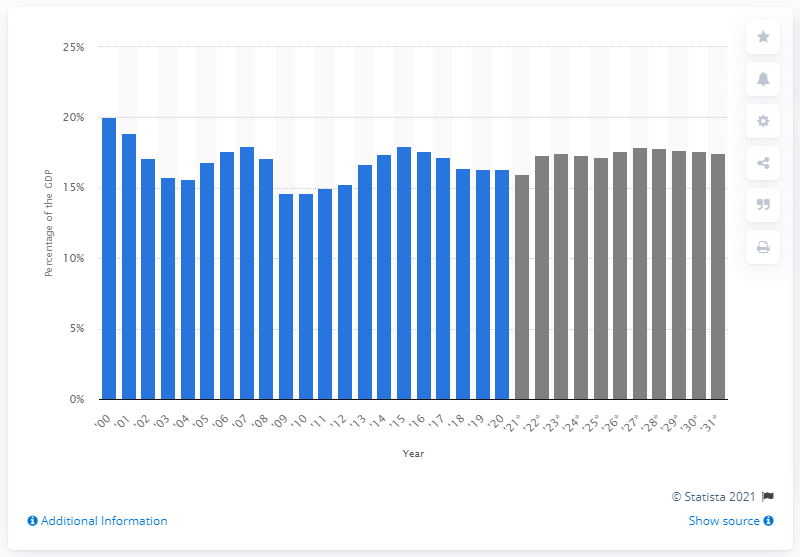Point out several critical features in this image. In 2020, federal revenue as a percentage of the U.S. GDP was 16.3%. 